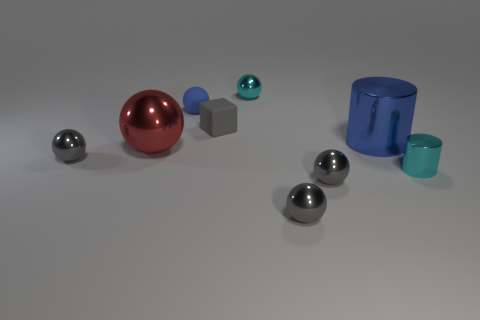Subtract all purple cylinders. How many gray spheres are left? 3 Subtract all cyan spheres. How many spheres are left? 5 Subtract all cyan metal balls. How many balls are left? 5 Subtract 3 spheres. How many spheres are left? 3 Subtract all purple spheres. Subtract all green cylinders. How many spheres are left? 6 Add 1 red shiny balls. How many objects exist? 10 Subtract all cylinders. How many objects are left? 7 Subtract 0 gray cylinders. How many objects are left? 9 Subtract all tiny cyan rubber blocks. Subtract all metal balls. How many objects are left? 4 Add 4 large cylinders. How many large cylinders are left? 5 